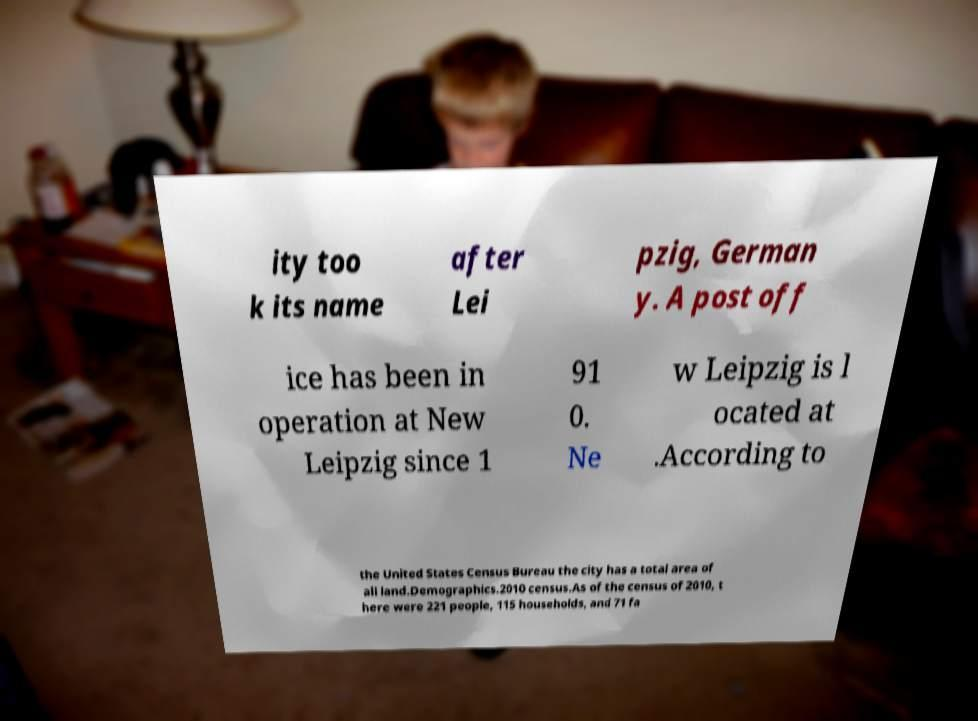I need the written content from this picture converted into text. Can you do that? ity too k its name after Lei pzig, German y. A post off ice has been in operation at New Leipzig since 1 91 0. Ne w Leipzig is l ocated at .According to the United States Census Bureau the city has a total area of all land.Demographics.2010 census.As of the census of 2010, t here were 221 people, 115 households, and 71 fa 